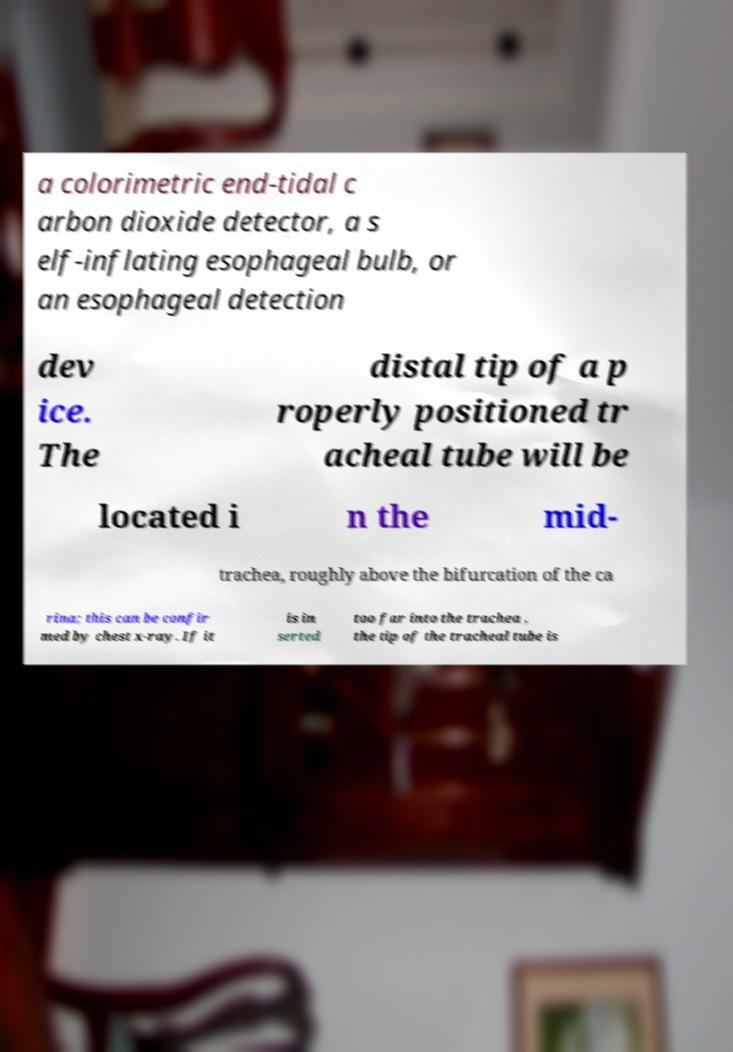Can you read and provide the text displayed in the image?This photo seems to have some interesting text. Can you extract and type it out for me? a colorimetric end-tidal c arbon dioxide detector, a s elf-inflating esophageal bulb, or an esophageal detection dev ice. The distal tip of a p roperly positioned tr acheal tube will be located i n the mid- trachea, roughly above the bifurcation of the ca rina; this can be confir med by chest x-ray. If it is in serted too far into the trachea , the tip of the tracheal tube is 